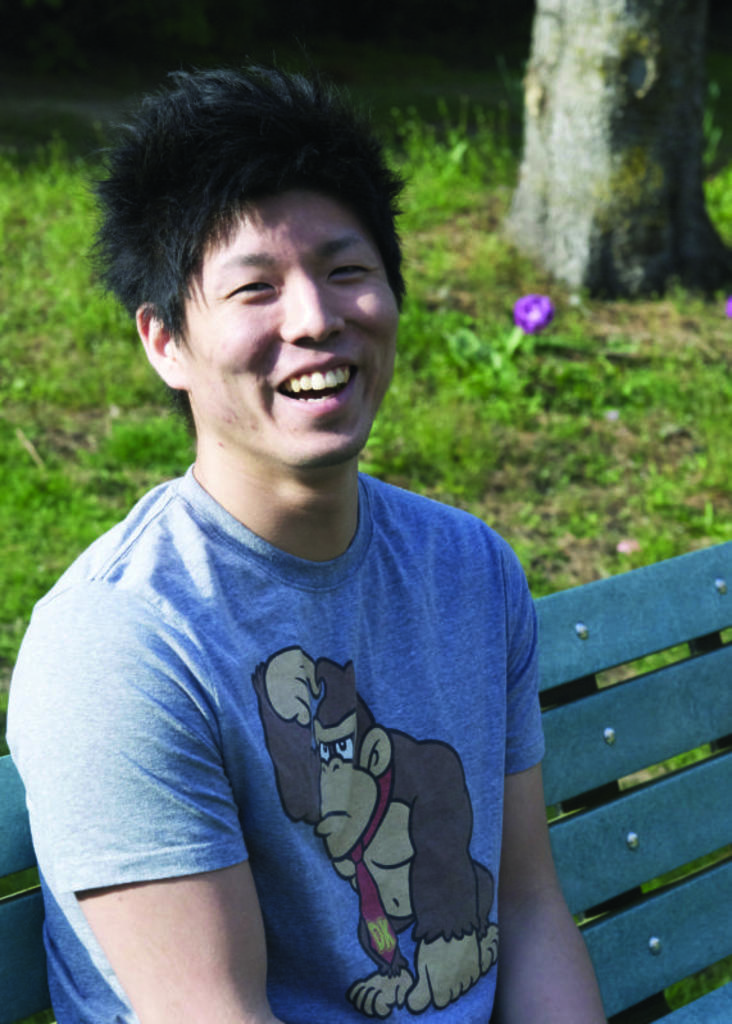What is the person in the image doing? The person is sitting on a bench in the image. What is the person's facial expression? The person is smiling. What can be seen on the ground behind the person? There is greenery on the ground behind the person. Where is the tree located in the image? There is a tree in the right top corner of the image. How many children are playing with the paper in the image? There is no paper or children present in the image. 